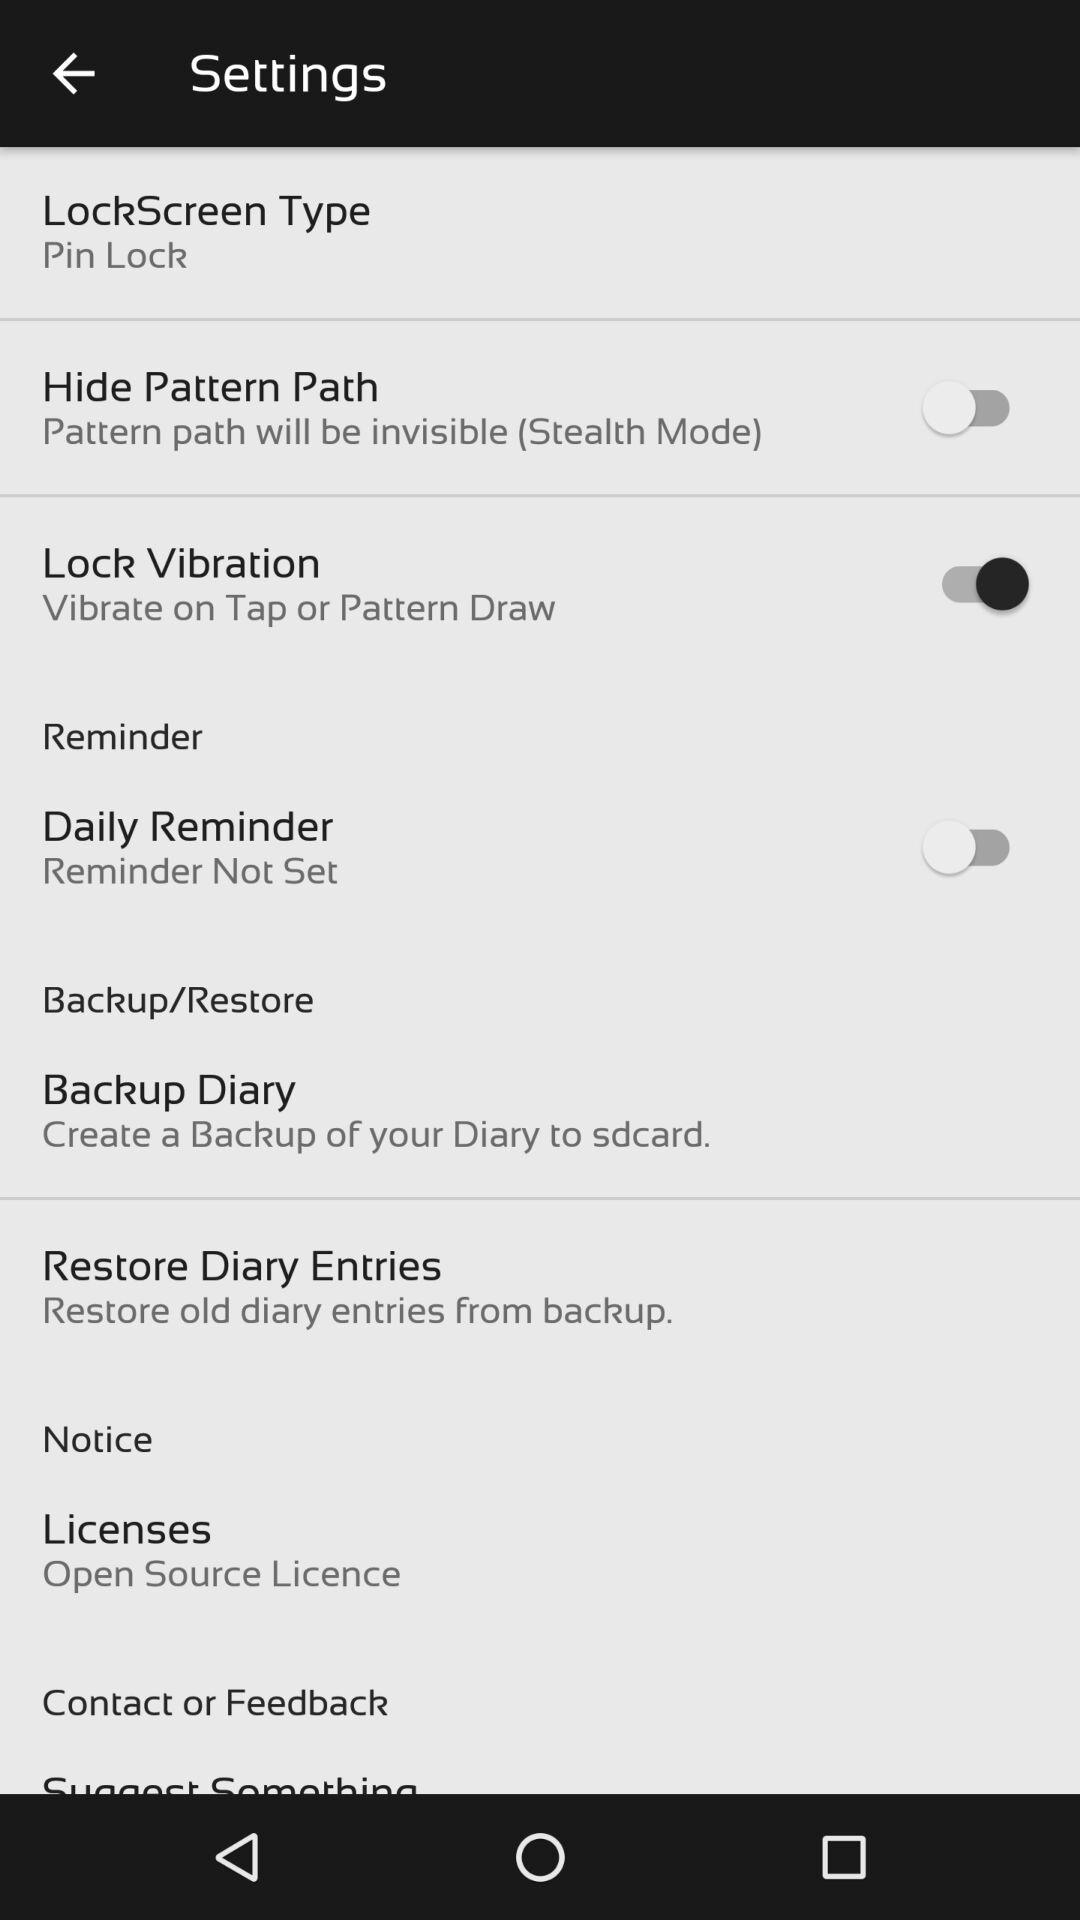What is the setting for "Lock Vibration"? The setting is "Vibrate on Tap or Pattern Draw". 